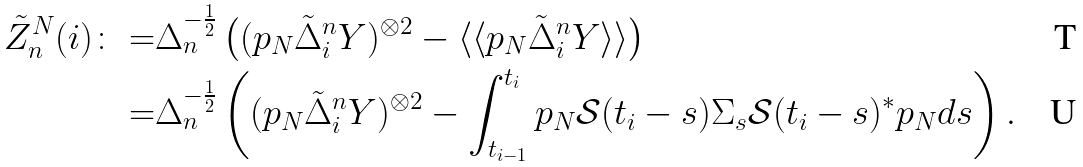Convert formula to latex. <formula><loc_0><loc_0><loc_500><loc_500>\tilde { Z } _ { n } ^ { N } ( i ) \colon = & \Delta _ { n } ^ { - \frac { 1 } { 2 } } \left ( ( p _ { N } \tilde { \Delta } _ { i } ^ { n } Y ) ^ { \otimes 2 } - \langle \langle p _ { N } \tilde { \Delta } _ { i } ^ { n } Y \rangle \rangle \right ) \\ = & \Delta _ { n } ^ { - \frac { 1 } { 2 } } \left ( ( p _ { N } \tilde { \Delta } _ { i } ^ { n } Y ) ^ { \otimes 2 } - \int _ { t _ { i - 1 } } ^ { t _ { i } } p _ { N } \mathcal { S } ( t _ { i } - s ) \Sigma _ { s } \mathcal { S } ( t _ { i } - s ) ^ { * } p _ { N } d s \right ) .</formula> 